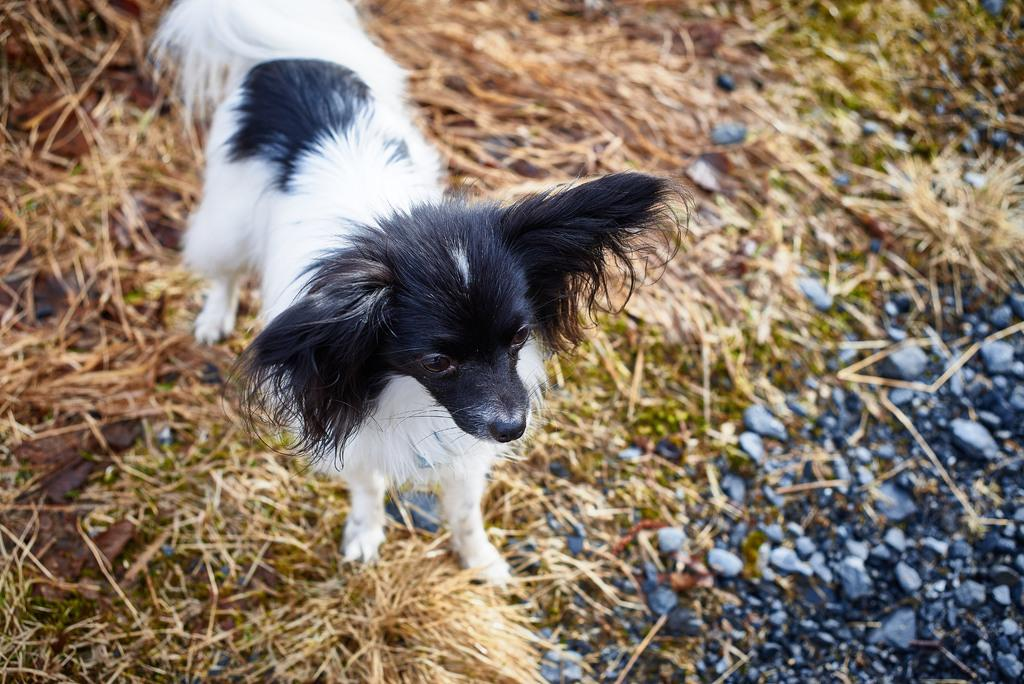What type of animal is in the image? There is a small puppy in the image. What is the puppy standing on? The puppy is standing on the grass. What can be seen on the ground in the image? There are stones on the ground in the image. What type of wood is the secretary using in the image? There is no wood or secretary present in the image; it features a small puppy standing on the grass with stones on the ground. 